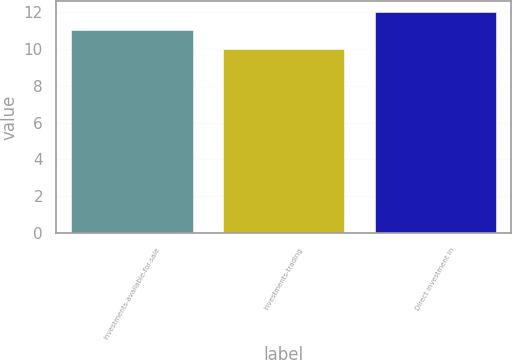Convert chart. <chart><loc_0><loc_0><loc_500><loc_500><bar_chart><fcel>Investments-available-for-sale<fcel>Investments-trading<fcel>Direct investment in<nl><fcel>11<fcel>10<fcel>12<nl></chart> 